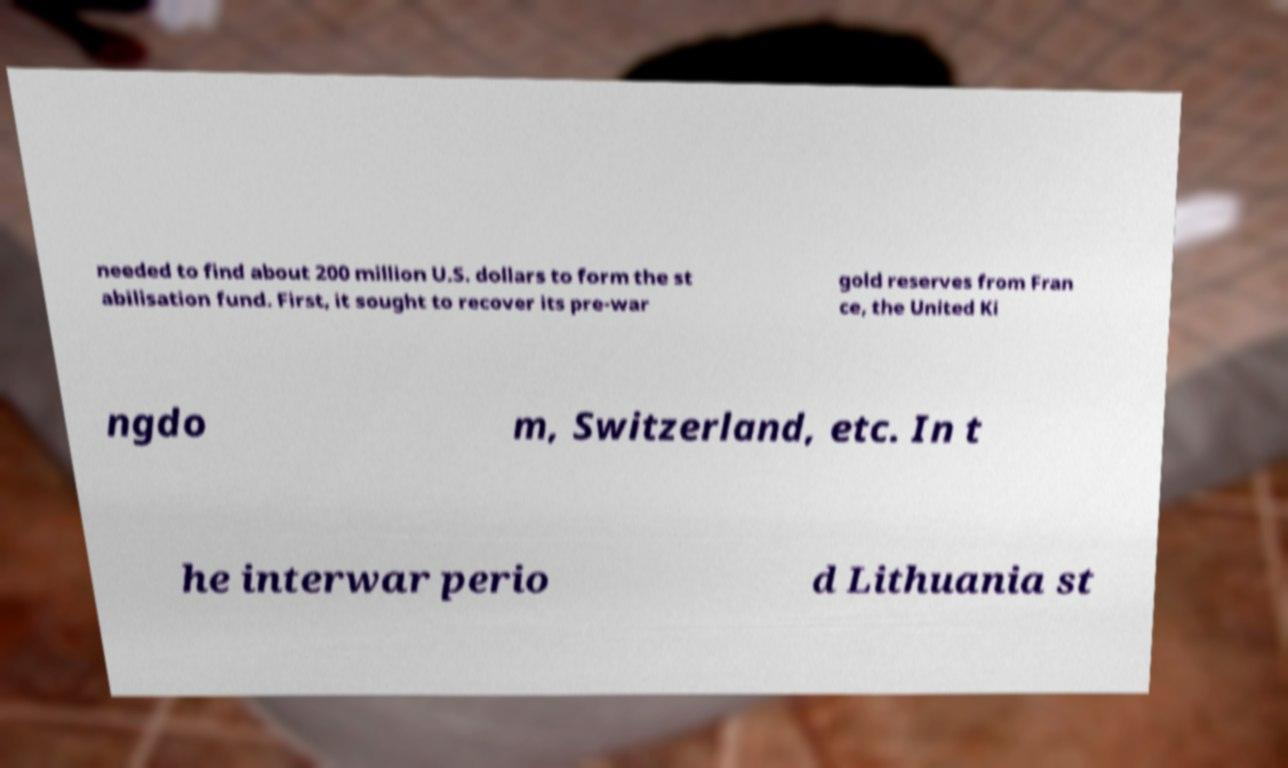Can you accurately transcribe the text from the provided image for me? needed to find about 200 million U.S. dollars to form the st abilisation fund. First, it sought to recover its pre-war gold reserves from Fran ce, the United Ki ngdo m, Switzerland, etc. In t he interwar perio d Lithuania st 